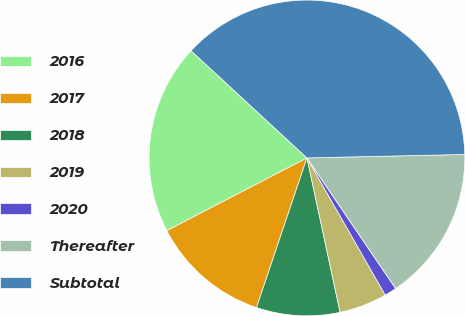<chart> <loc_0><loc_0><loc_500><loc_500><pie_chart><fcel>2016<fcel>2017<fcel>2018<fcel>2019<fcel>2020<fcel>Thereafter<fcel>Subtotal<nl><fcel>19.5%<fcel>12.2%<fcel>8.54%<fcel>4.89%<fcel>1.24%<fcel>15.85%<fcel>37.77%<nl></chart> 